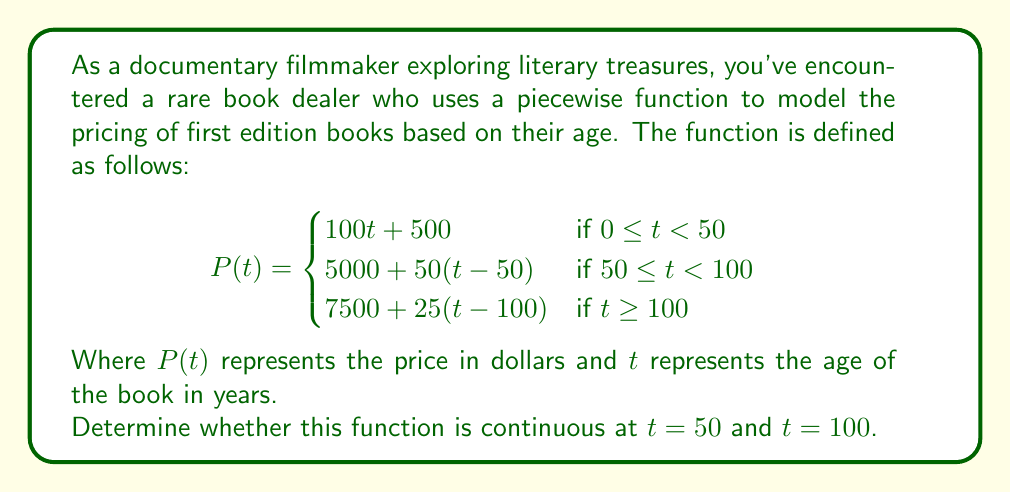Provide a solution to this math problem. To determine if the function is continuous at $t = 50$ and $t = 100$, we need to check three conditions at each point:

1. The function is defined at the point.
2. The limit of the function as we approach the point from both sides exists.
3. The limit equals the function value at that point.

For $t = 50$:

1. The function is defined at $t = 50$.
2. Left-hand limit:
   $\lim_{t \to 50^-} P(t) = \lim_{t \to 50^-} (100t + 500) = 100(50) + 500 = 5500$
   Right-hand limit:
   $\lim_{t \to 50^+} P(t) = \lim_{t \to 50^+} (5000 + 50(t-50)) = 5000 + 50(0) = 5000$
3. $P(50) = 5000 + 50(50-50) = 5000$

Since the left-hand limit ($5500) ≠ right-hand limit ($5000) ≠ P(50)$, the function is not continuous at $t = 50$.

For $t = 100$:

1. The function is defined at $t = 100$.
2. Left-hand limit:
   $\lim_{t \to 100^-} P(t) = \lim_{t \to 100^-} (5000 + 50(t-50)) = 5000 + 50(50) = 7500$
   Right-hand limit:
   $\lim_{t \to 100^+} P(t) = \lim_{t \to 100^+} (7500 + 25(t-100)) = 7500 + 25(0) = 7500$
3. $P(100) = 7500 + 25(100-100) = 7500$

Since the left-hand limit = right-hand limit = $P(100) = 7500$, the function is continuous at $t = 100$.
Answer: The function is discontinuous at $t = 50$ and continuous at $t = 100$. 